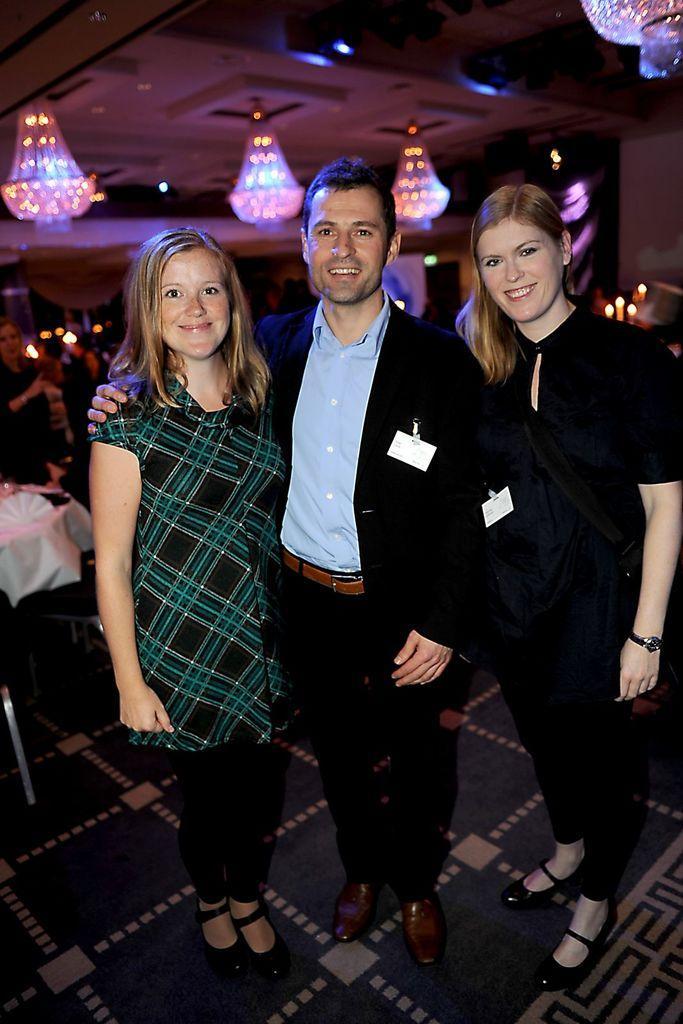Please provide a concise description of this image. As we can see in the image there are chandeliers, few people here and there and people in the front are wearing black color dresses. 